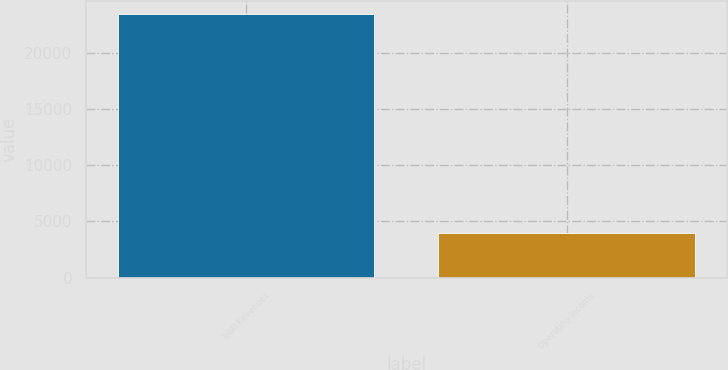Convert chart to OTSL. <chart><loc_0><loc_0><loc_500><loc_500><bar_chart><fcel>Total Revenues<fcel>Operating Income<nl><fcel>23414<fcel>3996<nl></chart> 